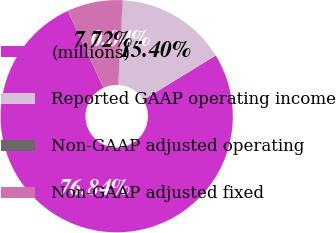<chart> <loc_0><loc_0><loc_500><loc_500><pie_chart><fcel>(millions)<fcel>Reported GAAP operating income<fcel>Non-GAAP adjusted operating<fcel>Non-GAAP adjusted fixed<nl><fcel>76.84%<fcel>15.4%<fcel>0.04%<fcel>7.72%<nl></chart> 